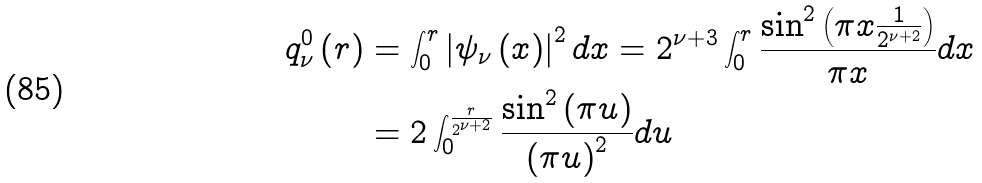<formula> <loc_0><loc_0><loc_500><loc_500>q _ { \nu } ^ { 0 } \left ( r \right ) & = \int _ { 0 } ^ { r } \left | \psi _ { \nu } \left ( x \right ) \right | ^ { 2 } d x = 2 ^ { \nu + 3 } \int _ { 0 } ^ { r } \frac { \sin ^ { 2 } \left ( \pi x \frac { 1 } { 2 ^ { \nu + 2 } } \right ) } { \pi x } d x \\ & = 2 \int _ { 0 } ^ { \frac { r } { 2 ^ { \nu + 2 } } } \frac { \sin ^ { 2 } \left ( \pi u \right ) } { \left ( \pi u \right ) ^ { 2 } } d u</formula> 